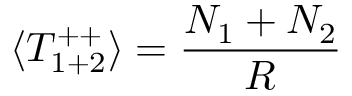Convert formula to latex. <formula><loc_0><loc_0><loc_500><loc_500>\langle T _ { 1 + 2 } ^ { + + } \rangle = \frac { N _ { 1 } + N _ { 2 } } { R }</formula> 